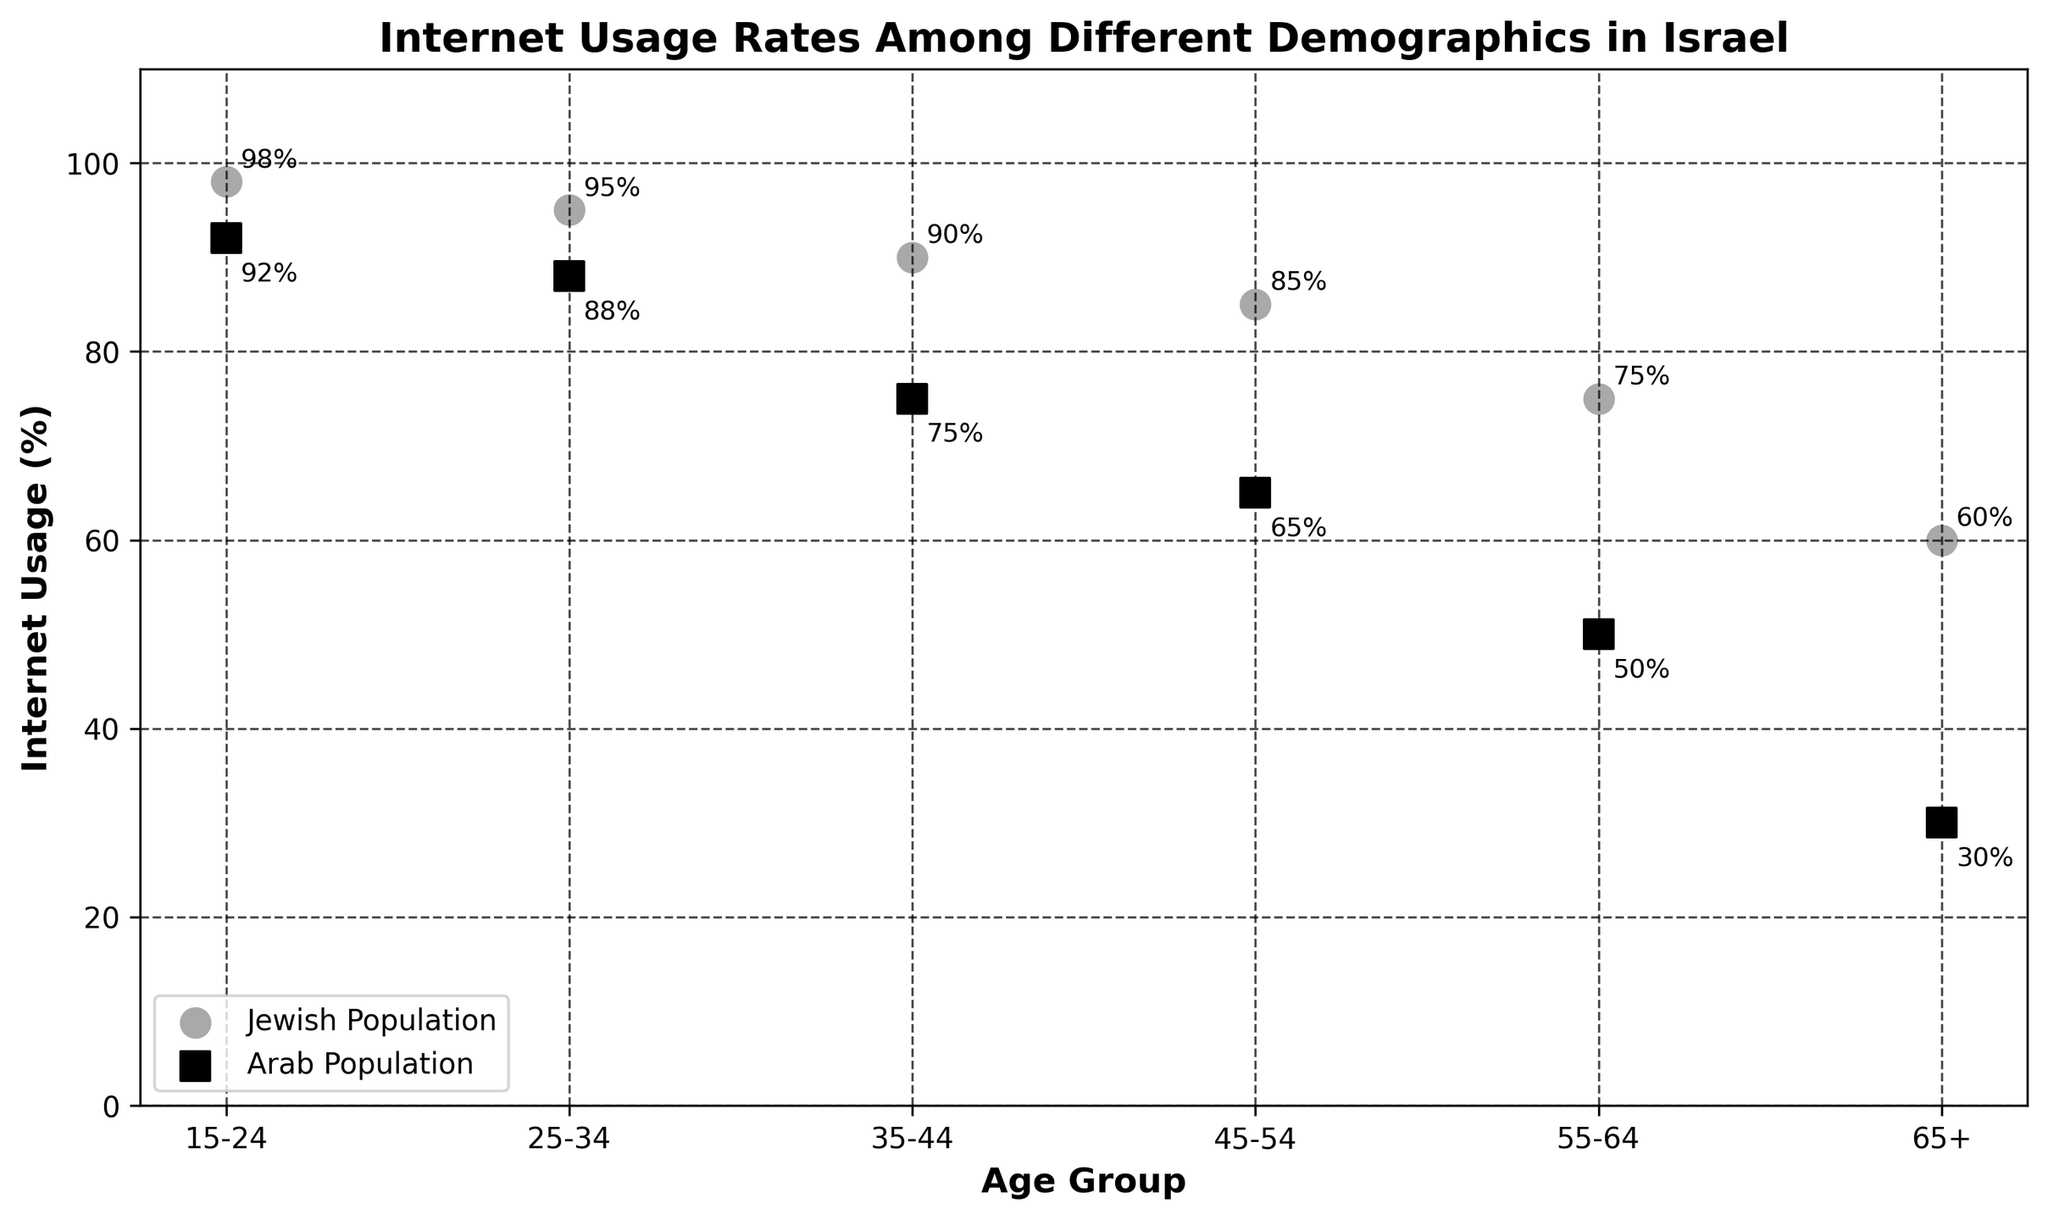What is the title of the plot? The title is located at the top of the figure, indicating the subject of the data presented.
Answer: Internet Usage Rates Among Different Demographics in Israel Which age group has the highest internet usage rate among the Jewish population? Look for the age group with the highest percentage value labeled next to the scatter points for the Jewish population.
Answer: 15-24 Which age group has the lowest internet usage rate among the Arab population? Identify the age group that has the smallest percentage value labeled next to the scatter points for the Arab population.
Answer: 65+ What is the difference in internet usage between the Jewish and Arab populations in the 35-44 age group? Subtract the internet usage percentage of the Arab population from that of the Jewish population for the 35-44 age group (90% for Jews and 75% for Arabs).
Answer: 15% How many different age groups are represented in the plot? Count the number of unique age groups listed on the x-axis.
Answer: 6 What is the internet usage rate for the Arab population in the 45-54 age group? Find the percentage value labeled next to the scatter point for the Arab population in the 45-54 age group.
Answer: 65% Is the internet usage rate for the Jewish population higher or lower than the Arab population in every age group? Compare the internet usage percentage for each age group between the Jewish and Arab populations.
Answer: Higher What is the average internet usage rate for the Jewish population across all age groups? Sum the internet usage rates for the Jewish population across all age groups and divide by the number of age groups (98% + 95% + 90% + 85% + 75% + 60%) / 6.
Answer: 83.83% Which age group has the largest gap in internet usage between the Jewish and Arab populations? Calculate the difference between the internet usage rates of the Jewish and Arab populations for each age group and identify the age group with the largest value.
Answer: 65+ What is the overall trend in internet usage rates as age increases for both populations? Observe the scatter points for both populations and note how the usage rates change as the age groups move from younger to older.
Answer: Decreasing 